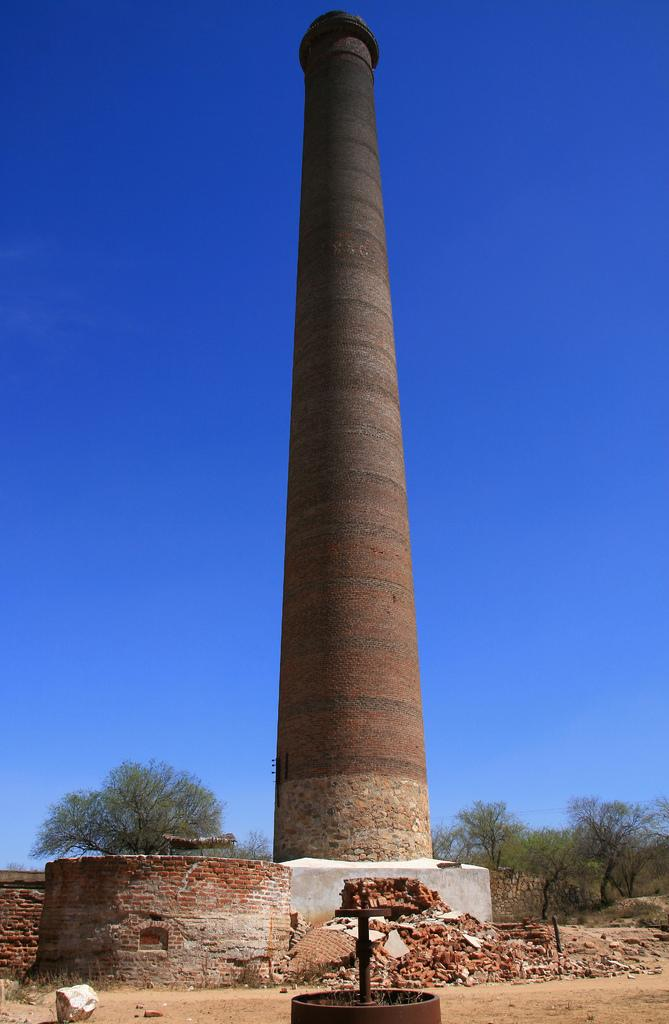What is the main structure in the center of the image? There is a tower in the center of the image. What other architectural feature can be seen in the image? There is a wall in the image. Are there any other objects or structures in the image? Yes, there is a pole in the image. What is the color of the object in the image? There is a black color object in the image. What material is used for the wall in the image? The wall is made of bricks, which are visible in the image. What can be seen in the background of the image? The sky and trees are visible in the background of the image. Where is the daughter playing with her patch in the image? There is no daughter or patch present in the image. What type of bucket is used to collect water from the tower in the image? There is no bucket or water collection activity depicted in the image. 